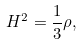<formula> <loc_0><loc_0><loc_500><loc_500>H ^ { 2 } = \frac { 1 } { 3 } \rho ,</formula> 